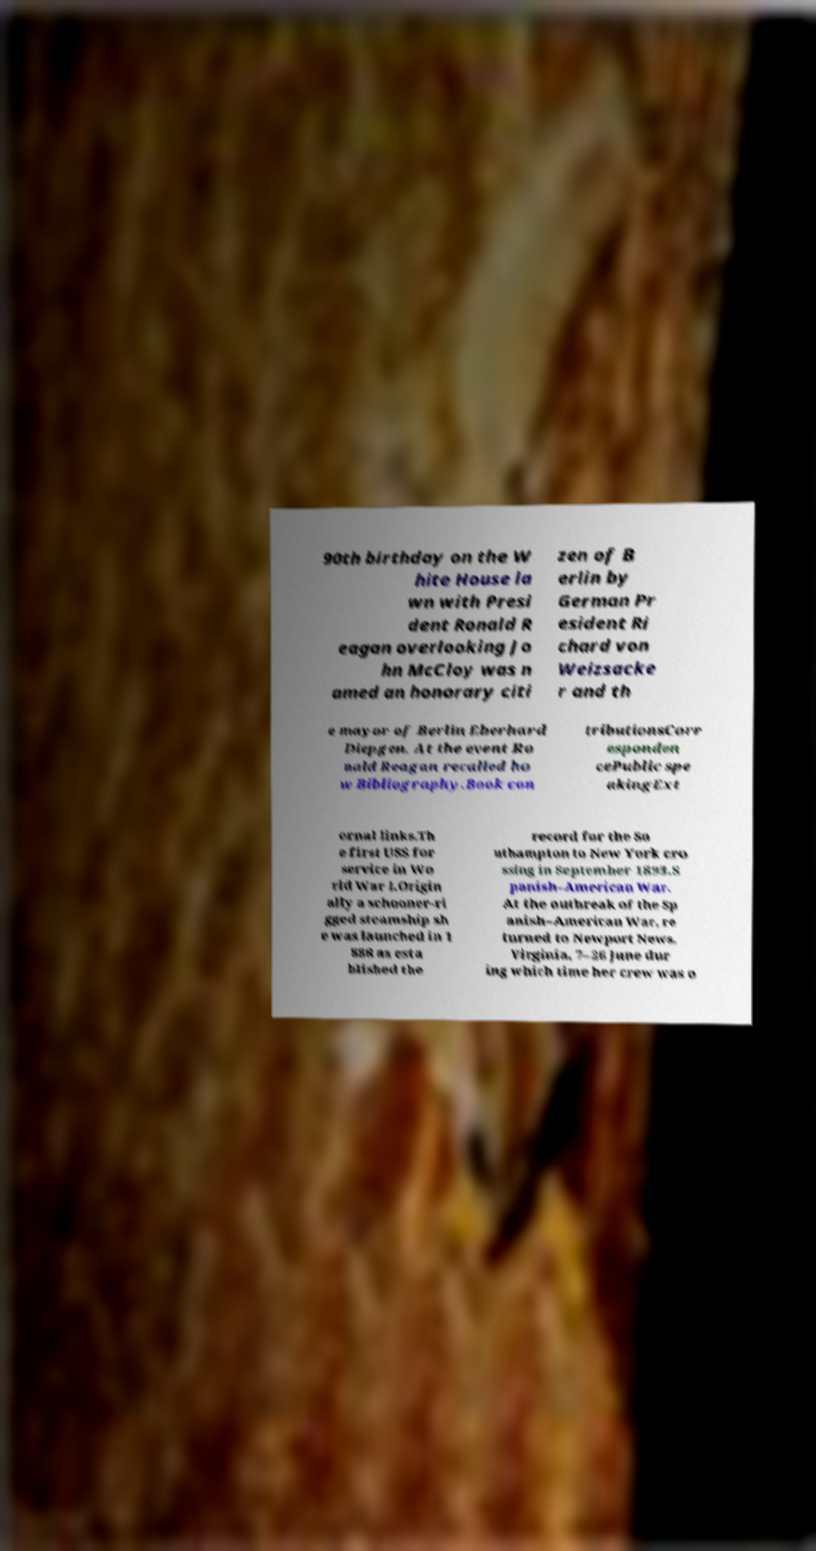What messages or text are displayed in this image? I need them in a readable, typed format. 90th birthday on the W hite House la wn with Presi dent Ronald R eagan overlooking Jo hn McCloy was n amed an honorary citi zen of B erlin by German Pr esident Ri chard von Weizsacke r and th e mayor of Berlin Eberhard Diepgen. At the event Ro nald Reagan recalled ho w Bibliography.Book con tributionsCorr esponden cePublic spe akingExt ernal links.Th e first USS for service in Wo rld War I.Origin ally a schooner-ri gged steamship sh e was launched in 1 888 as esta blished the record for the So uthampton to New York cro ssing in September 1893.S panish–American War. At the outbreak of the Sp anish–American War, re turned to Newport News, Virginia, 7–26 June dur ing which time her crew was o 